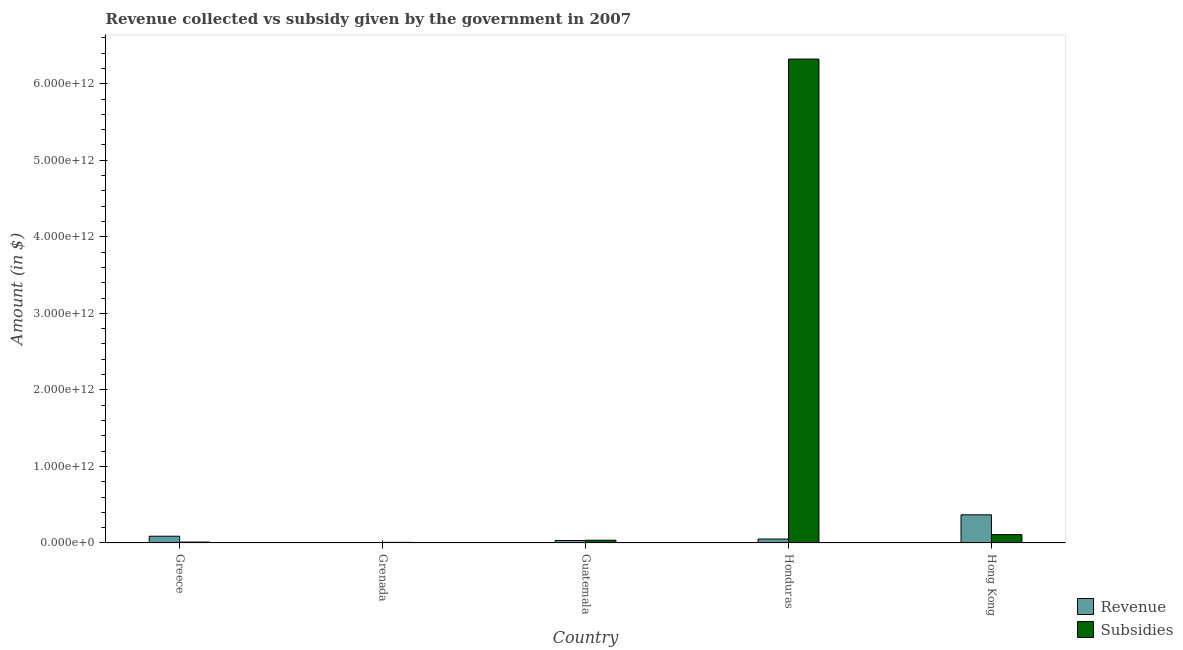Are the number of bars per tick equal to the number of legend labels?
Ensure brevity in your answer.  Yes. Are the number of bars on each tick of the X-axis equal?
Give a very brief answer. Yes. What is the label of the 3rd group of bars from the left?
Give a very brief answer. Guatemala. What is the amount of revenue collected in Greece?
Offer a terse response. 8.83e+1. Across all countries, what is the maximum amount of revenue collected?
Your answer should be compact. 3.68e+11. Across all countries, what is the minimum amount of revenue collected?
Your answer should be compact. 4.28e+08. In which country was the amount of subsidies given maximum?
Your answer should be very brief. Honduras. In which country was the amount of revenue collected minimum?
Your answer should be compact. Grenada. What is the total amount of subsidies given in the graph?
Give a very brief answer. 6.49e+12. What is the difference between the amount of revenue collected in Guatemala and that in Hong Kong?
Make the answer very short. -3.35e+11. What is the difference between the amount of revenue collected in Honduras and the amount of subsidies given in Greece?
Your answer should be compact. 3.97e+1. What is the average amount of revenue collected per country?
Provide a succinct answer. 1.08e+11. What is the difference between the amount of revenue collected and amount of subsidies given in Honduras?
Offer a very short reply. -6.27e+12. What is the ratio of the amount of subsidies given in Grenada to that in Guatemala?
Provide a short and direct response. 0.22. Is the amount of revenue collected in Guatemala less than that in Honduras?
Your answer should be very brief. Yes. What is the difference between the highest and the second highest amount of subsidies given?
Your answer should be very brief. 6.21e+12. What is the difference between the highest and the lowest amount of subsidies given?
Offer a terse response. 6.31e+12. In how many countries, is the amount of revenue collected greater than the average amount of revenue collected taken over all countries?
Provide a short and direct response. 1. What does the 2nd bar from the left in Guatemala represents?
Provide a succinct answer. Subsidies. What does the 1st bar from the right in Guatemala represents?
Keep it short and to the point. Subsidies. Are all the bars in the graph horizontal?
Provide a succinct answer. No. What is the difference between two consecutive major ticks on the Y-axis?
Make the answer very short. 1.00e+12. Are the values on the major ticks of Y-axis written in scientific E-notation?
Offer a terse response. Yes. Does the graph contain any zero values?
Give a very brief answer. No. Where does the legend appear in the graph?
Give a very brief answer. Bottom right. How are the legend labels stacked?
Your answer should be compact. Vertical. What is the title of the graph?
Offer a very short reply. Revenue collected vs subsidy given by the government in 2007. Does "Passenger Transport Items" appear as one of the legend labels in the graph?
Ensure brevity in your answer.  No. What is the label or title of the X-axis?
Your answer should be compact. Country. What is the label or title of the Y-axis?
Offer a very short reply. Amount (in $). What is the Amount (in $) of Revenue in Greece?
Offer a very short reply. 8.83e+1. What is the Amount (in $) in Subsidies in Greece?
Keep it short and to the point. 1.19e+1. What is the Amount (in $) in Revenue in Grenada?
Your answer should be very brief. 4.28e+08. What is the Amount (in $) of Subsidies in Grenada?
Offer a very short reply. 8.13e+09. What is the Amount (in $) in Revenue in Guatemala?
Make the answer very short. 3.31e+1. What is the Amount (in $) of Subsidies in Guatemala?
Provide a succinct answer. 3.64e+1. What is the Amount (in $) in Revenue in Honduras?
Your answer should be very brief. 5.15e+1. What is the Amount (in $) in Subsidies in Honduras?
Offer a terse response. 6.32e+12. What is the Amount (in $) in Revenue in Hong Kong?
Offer a terse response. 3.68e+11. What is the Amount (in $) in Subsidies in Hong Kong?
Provide a succinct answer. 1.09e+11. Across all countries, what is the maximum Amount (in $) of Revenue?
Offer a terse response. 3.68e+11. Across all countries, what is the maximum Amount (in $) of Subsidies?
Provide a succinct answer. 6.32e+12. Across all countries, what is the minimum Amount (in $) in Revenue?
Make the answer very short. 4.28e+08. Across all countries, what is the minimum Amount (in $) of Subsidies?
Your answer should be compact. 8.13e+09. What is the total Amount (in $) in Revenue in the graph?
Offer a very short reply. 5.42e+11. What is the total Amount (in $) of Subsidies in the graph?
Your answer should be compact. 6.49e+12. What is the difference between the Amount (in $) in Revenue in Greece and that in Grenada?
Provide a succinct answer. 8.78e+1. What is the difference between the Amount (in $) in Subsidies in Greece and that in Grenada?
Make the answer very short. 3.72e+09. What is the difference between the Amount (in $) of Revenue in Greece and that in Guatemala?
Provide a short and direct response. 5.52e+1. What is the difference between the Amount (in $) of Subsidies in Greece and that in Guatemala?
Your answer should be compact. -2.45e+1. What is the difference between the Amount (in $) in Revenue in Greece and that in Honduras?
Your answer should be very brief. 3.67e+1. What is the difference between the Amount (in $) of Subsidies in Greece and that in Honduras?
Offer a very short reply. -6.31e+12. What is the difference between the Amount (in $) of Revenue in Greece and that in Hong Kong?
Make the answer very short. -2.80e+11. What is the difference between the Amount (in $) in Subsidies in Greece and that in Hong Kong?
Offer a very short reply. -9.76e+1. What is the difference between the Amount (in $) of Revenue in Grenada and that in Guatemala?
Keep it short and to the point. -3.27e+1. What is the difference between the Amount (in $) of Subsidies in Grenada and that in Guatemala?
Offer a very short reply. -2.82e+1. What is the difference between the Amount (in $) in Revenue in Grenada and that in Honduras?
Give a very brief answer. -5.11e+1. What is the difference between the Amount (in $) in Subsidies in Grenada and that in Honduras?
Ensure brevity in your answer.  -6.31e+12. What is the difference between the Amount (in $) in Revenue in Grenada and that in Hong Kong?
Your answer should be very brief. -3.68e+11. What is the difference between the Amount (in $) in Subsidies in Grenada and that in Hong Kong?
Offer a very short reply. -1.01e+11. What is the difference between the Amount (in $) in Revenue in Guatemala and that in Honduras?
Offer a very short reply. -1.84e+1. What is the difference between the Amount (in $) in Subsidies in Guatemala and that in Honduras?
Your answer should be very brief. -6.29e+12. What is the difference between the Amount (in $) of Revenue in Guatemala and that in Hong Kong?
Offer a terse response. -3.35e+11. What is the difference between the Amount (in $) in Subsidies in Guatemala and that in Hong Kong?
Your response must be concise. -7.31e+1. What is the difference between the Amount (in $) in Revenue in Honduras and that in Hong Kong?
Provide a short and direct response. -3.17e+11. What is the difference between the Amount (in $) of Subsidies in Honduras and that in Hong Kong?
Your response must be concise. 6.21e+12. What is the difference between the Amount (in $) in Revenue in Greece and the Amount (in $) in Subsidies in Grenada?
Provide a succinct answer. 8.01e+1. What is the difference between the Amount (in $) in Revenue in Greece and the Amount (in $) in Subsidies in Guatemala?
Offer a very short reply. 5.19e+1. What is the difference between the Amount (in $) in Revenue in Greece and the Amount (in $) in Subsidies in Honduras?
Offer a terse response. -6.23e+12. What is the difference between the Amount (in $) in Revenue in Greece and the Amount (in $) in Subsidies in Hong Kong?
Make the answer very short. -2.12e+1. What is the difference between the Amount (in $) in Revenue in Grenada and the Amount (in $) in Subsidies in Guatemala?
Provide a succinct answer. -3.59e+1. What is the difference between the Amount (in $) in Revenue in Grenada and the Amount (in $) in Subsidies in Honduras?
Your answer should be very brief. -6.32e+12. What is the difference between the Amount (in $) of Revenue in Grenada and the Amount (in $) of Subsidies in Hong Kong?
Provide a short and direct response. -1.09e+11. What is the difference between the Amount (in $) in Revenue in Guatemala and the Amount (in $) in Subsidies in Honduras?
Offer a very short reply. -6.29e+12. What is the difference between the Amount (in $) in Revenue in Guatemala and the Amount (in $) in Subsidies in Hong Kong?
Keep it short and to the point. -7.64e+1. What is the difference between the Amount (in $) in Revenue in Honduras and the Amount (in $) in Subsidies in Hong Kong?
Ensure brevity in your answer.  -5.79e+1. What is the average Amount (in $) of Revenue per country?
Your response must be concise. 1.08e+11. What is the average Amount (in $) in Subsidies per country?
Give a very brief answer. 1.30e+12. What is the difference between the Amount (in $) of Revenue and Amount (in $) of Subsidies in Greece?
Provide a succinct answer. 7.64e+1. What is the difference between the Amount (in $) in Revenue and Amount (in $) in Subsidies in Grenada?
Offer a very short reply. -7.70e+09. What is the difference between the Amount (in $) of Revenue and Amount (in $) of Subsidies in Guatemala?
Offer a terse response. -3.25e+09. What is the difference between the Amount (in $) of Revenue and Amount (in $) of Subsidies in Honduras?
Your response must be concise. -6.27e+12. What is the difference between the Amount (in $) in Revenue and Amount (in $) in Subsidies in Hong Kong?
Your response must be concise. 2.59e+11. What is the ratio of the Amount (in $) of Revenue in Greece to that in Grenada?
Your response must be concise. 206.04. What is the ratio of the Amount (in $) of Subsidies in Greece to that in Grenada?
Make the answer very short. 1.46. What is the ratio of the Amount (in $) of Revenue in Greece to that in Guatemala?
Your response must be concise. 2.67. What is the ratio of the Amount (in $) of Subsidies in Greece to that in Guatemala?
Give a very brief answer. 0.33. What is the ratio of the Amount (in $) of Revenue in Greece to that in Honduras?
Ensure brevity in your answer.  1.71. What is the ratio of the Amount (in $) in Subsidies in Greece to that in Honduras?
Provide a succinct answer. 0. What is the ratio of the Amount (in $) of Revenue in Greece to that in Hong Kong?
Provide a short and direct response. 0.24. What is the ratio of the Amount (in $) in Subsidies in Greece to that in Hong Kong?
Your response must be concise. 0.11. What is the ratio of the Amount (in $) in Revenue in Grenada to that in Guatemala?
Your response must be concise. 0.01. What is the ratio of the Amount (in $) in Subsidies in Grenada to that in Guatemala?
Make the answer very short. 0.22. What is the ratio of the Amount (in $) of Revenue in Grenada to that in Honduras?
Make the answer very short. 0.01. What is the ratio of the Amount (in $) of Subsidies in Grenada to that in Honduras?
Your answer should be compact. 0. What is the ratio of the Amount (in $) of Revenue in Grenada to that in Hong Kong?
Provide a succinct answer. 0. What is the ratio of the Amount (in $) in Subsidies in Grenada to that in Hong Kong?
Your answer should be compact. 0.07. What is the ratio of the Amount (in $) in Revenue in Guatemala to that in Honduras?
Your answer should be compact. 0.64. What is the ratio of the Amount (in $) of Subsidies in Guatemala to that in Honduras?
Your answer should be compact. 0.01. What is the ratio of the Amount (in $) of Revenue in Guatemala to that in Hong Kong?
Offer a terse response. 0.09. What is the ratio of the Amount (in $) of Subsidies in Guatemala to that in Hong Kong?
Your answer should be compact. 0.33. What is the ratio of the Amount (in $) of Revenue in Honduras to that in Hong Kong?
Your response must be concise. 0.14. What is the ratio of the Amount (in $) in Subsidies in Honduras to that in Hong Kong?
Make the answer very short. 57.76. What is the difference between the highest and the second highest Amount (in $) in Revenue?
Offer a terse response. 2.80e+11. What is the difference between the highest and the second highest Amount (in $) of Subsidies?
Provide a succinct answer. 6.21e+12. What is the difference between the highest and the lowest Amount (in $) of Revenue?
Provide a short and direct response. 3.68e+11. What is the difference between the highest and the lowest Amount (in $) in Subsidies?
Ensure brevity in your answer.  6.31e+12. 